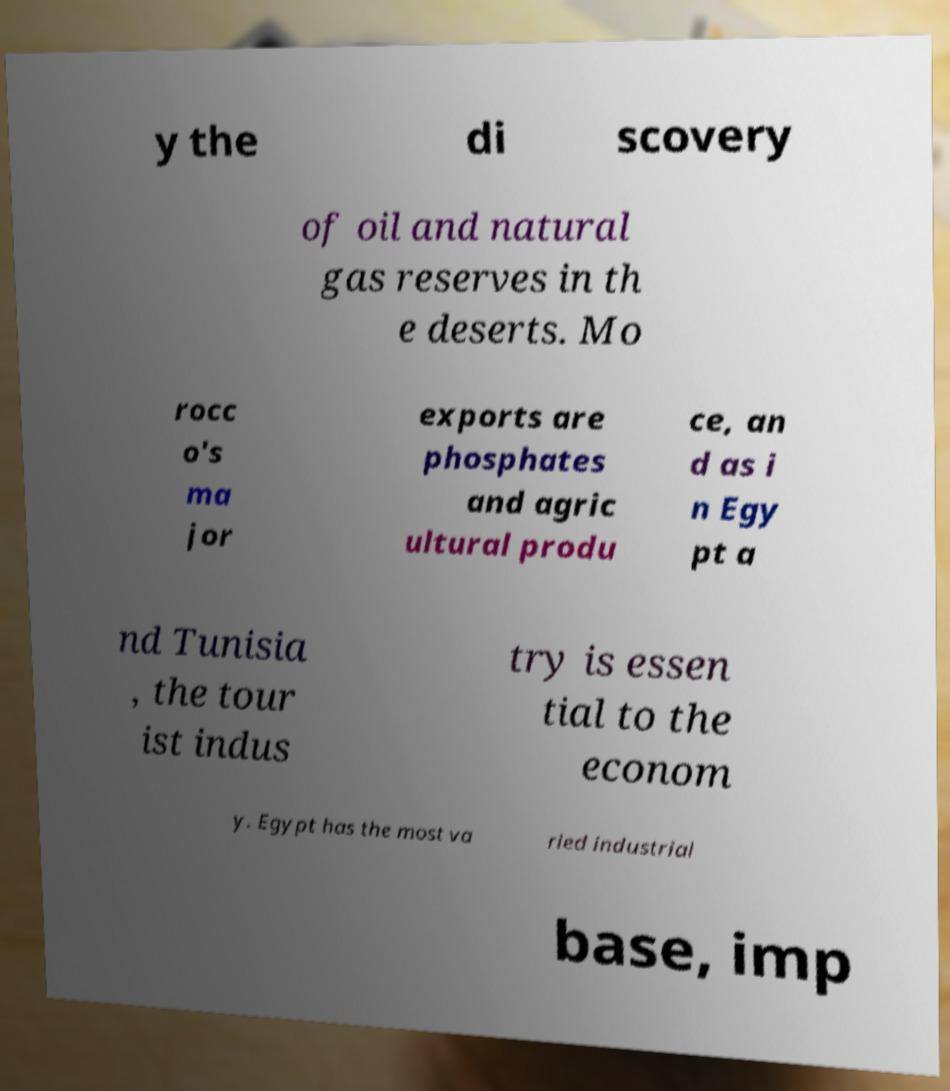For documentation purposes, I need the text within this image transcribed. Could you provide that? y the di scovery of oil and natural gas reserves in th e deserts. Mo rocc o's ma jor exports are phosphates and agric ultural produ ce, an d as i n Egy pt a nd Tunisia , the tour ist indus try is essen tial to the econom y. Egypt has the most va ried industrial base, imp 